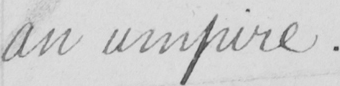Can you tell me what this handwritten text says? an umpire. 